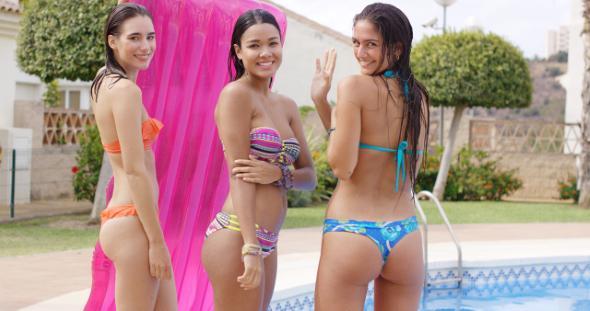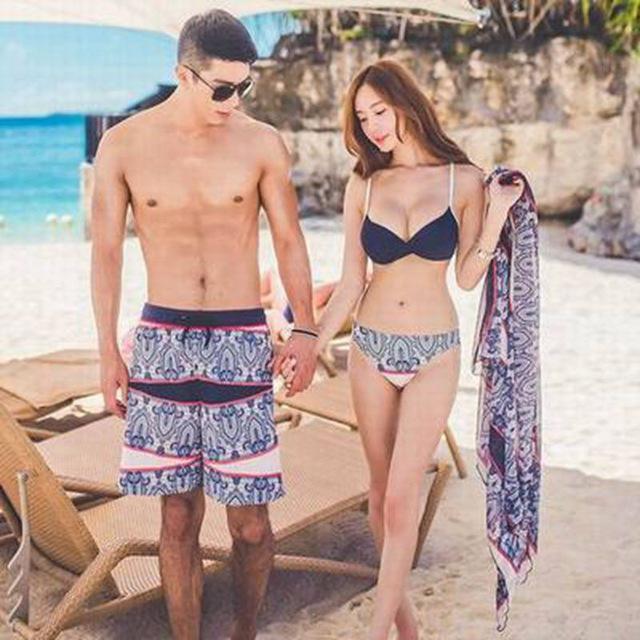The first image is the image on the left, the second image is the image on the right. Evaluate the accuracy of this statement regarding the images: "In the left image, women in bikinis are sitting on the edge of the water with their feet dangling in or above the water". Is it true? Answer yes or no. No. 